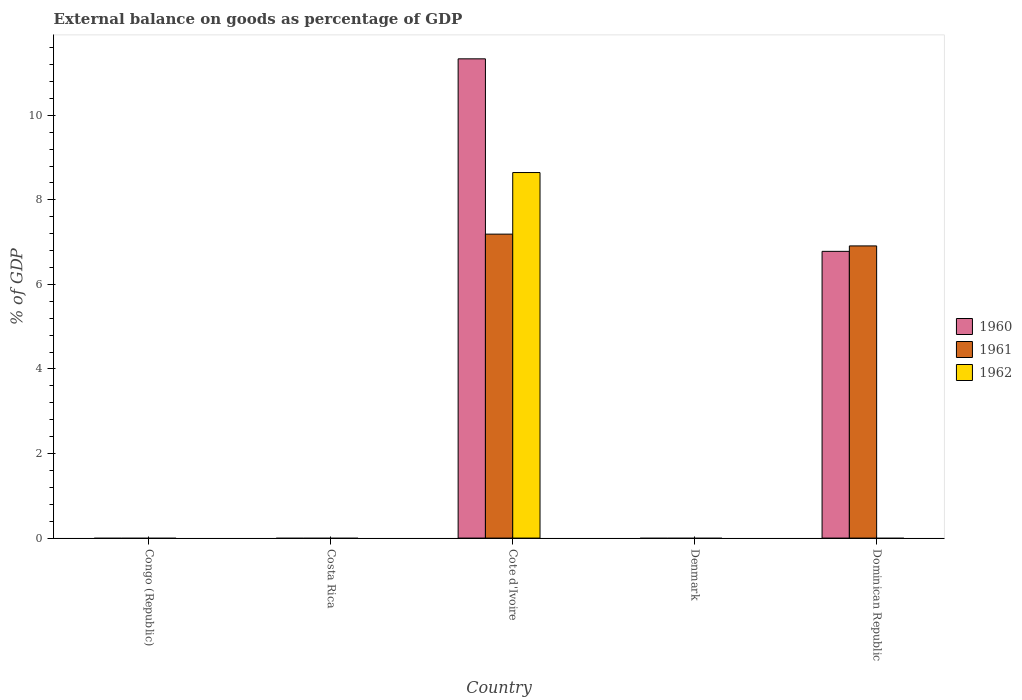How many different coloured bars are there?
Ensure brevity in your answer.  3. Are the number of bars on each tick of the X-axis equal?
Offer a terse response. No. How many bars are there on the 1st tick from the left?
Keep it short and to the point. 0. What is the external balance on goods as percentage of GDP in 1962 in Cote d'Ivoire?
Your response must be concise. 8.65. Across all countries, what is the maximum external balance on goods as percentage of GDP in 1960?
Keep it short and to the point. 11.34. Across all countries, what is the minimum external balance on goods as percentage of GDP in 1962?
Ensure brevity in your answer.  0. In which country was the external balance on goods as percentage of GDP in 1961 maximum?
Provide a short and direct response. Cote d'Ivoire. What is the total external balance on goods as percentage of GDP in 1960 in the graph?
Your answer should be compact. 18.12. What is the difference between the external balance on goods as percentage of GDP in 1962 in Costa Rica and the external balance on goods as percentage of GDP in 1961 in Cote d'Ivoire?
Provide a short and direct response. -7.19. What is the average external balance on goods as percentage of GDP in 1960 per country?
Offer a very short reply. 3.62. What is the difference between the external balance on goods as percentage of GDP of/in 1962 and external balance on goods as percentage of GDP of/in 1961 in Cote d'Ivoire?
Make the answer very short. 1.46. What is the difference between the highest and the lowest external balance on goods as percentage of GDP in 1960?
Offer a terse response. 11.34. In how many countries, is the external balance on goods as percentage of GDP in 1962 greater than the average external balance on goods as percentage of GDP in 1962 taken over all countries?
Provide a succinct answer. 1. How many countries are there in the graph?
Provide a succinct answer. 5. What is the difference between two consecutive major ticks on the Y-axis?
Your answer should be compact. 2. Are the values on the major ticks of Y-axis written in scientific E-notation?
Your response must be concise. No. Does the graph contain grids?
Give a very brief answer. No. What is the title of the graph?
Offer a terse response. External balance on goods as percentage of GDP. Does "1995" appear as one of the legend labels in the graph?
Ensure brevity in your answer.  No. What is the label or title of the Y-axis?
Ensure brevity in your answer.  % of GDP. What is the % of GDP in 1961 in Congo (Republic)?
Keep it short and to the point. 0. What is the % of GDP of 1962 in Congo (Republic)?
Make the answer very short. 0. What is the % of GDP of 1960 in Costa Rica?
Your answer should be compact. 0. What is the % of GDP of 1961 in Costa Rica?
Provide a short and direct response. 0. What is the % of GDP in 1962 in Costa Rica?
Make the answer very short. 0. What is the % of GDP of 1960 in Cote d'Ivoire?
Your answer should be very brief. 11.34. What is the % of GDP of 1961 in Cote d'Ivoire?
Your response must be concise. 7.19. What is the % of GDP of 1962 in Cote d'Ivoire?
Give a very brief answer. 8.65. What is the % of GDP in 1961 in Denmark?
Offer a terse response. 0. What is the % of GDP of 1960 in Dominican Republic?
Offer a very short reply. 6.78. What is the % of GDP in 1961 in Dominican Republic?
Your answer should be compact. 6.91. What is the % of GDP in 1962 in Dominican Republic?
Ensure brevity in your answer.  0. Across all countries, what is the maximum % of GDP in 1960?
Your answer should be compact. 11.34. Across all countries, what is the maximum % of GDP of 1961?
Offer a terse response. 7.19. Across all countries, what is the maximum % of GDP in 1962?
Your response must be concise. 8.65. Across all countries, what is the minimum % of GDP in 1960?
Give a very brief answer. 0. What is the total % of GDP in 1960 in the graph?
Your answer should be compact. 18.12. What is the total % of GDP of 1961 in the graph?
Your answer should be compact. 14.1. What is the total % of GDP of 1962 in the graph?
Offer a very short reply. 8.65. What is the difference between the % of GDP in 1960 in Cote d'Ivoire and that in Dominican Republic?
Your response must be concise. 4.55. What is the difference between the % of GDP of 1961 in Cote d'Ivoire and that in Dominican Republic?
Ensure brevity in your answer.  0.28. What is the difference between the % of GDP in 1960 in Cote d'Ivoire and the % of GDP in 1961 in Dominican Republic?
Offer a very short reply. 4.42. What is the average % of GDP in 1960 per country?
Your response must be concise. 3.62. What is the average % of GDP of 1961 per country?
Offer a terse response. 2.82. What is the average % of GDP of 1962 per country?
Provide a short and direct response. 1.73. What is the difference between the % of GDP in 1960 and % of GDP in 1961 in Cote d'Ivoire?
Keep it short and to the point. 4.15. What is the difference between the % of GDP in 1960 and % of GDP in 1962 in Cote d'Ivoire?
Your answer should be very brief. 2.69. What is the difference between the % of GDP of 1961 and % of GDP of 1962 in Cote d'Ivoire?
Your answer should be compact. -1.46. What is the difference between the % of GDP of 1960 and % of GDP of 1961 in Dominican Republic?
Provide a succinct answer. -0.13. What is the ratio of the % of GDP of 1960 in Cote d'Ivoire to that in Dominican Republic?
Keep it short and to the point. 1.67. What is the ratio of the % of GDP of 1961 in Cote d'Ivoire to that in Dominican Republic?
Your answer should be compact. 1.04. What is the difference between the highest and the lowest % of GDP in 1960?
Give a very brief answer. 11.34. What is the difference between the highest and the lowest % of GDP in 1961?
Make the answer very short. 7.19. What is the difference between the highest and the lowest % of GDP of 1962?
Keep it short and to the point. 8.65. 